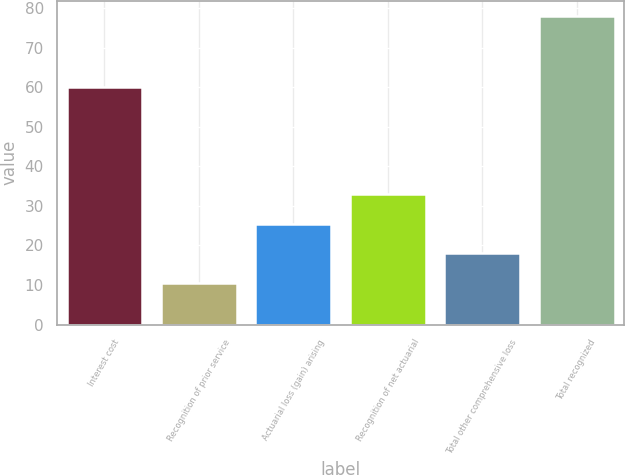<chart> <loc_0><loc_0><loc_500><loc_500><bar_chart><fcel>Interest cost<fcel>Recognition of prior service<fcel>Actuarial loss (gain) arising<fcel>Recognition of net actuarial<fcel>Total other comprehensive loss<fcel>Total recognized<nl><fcel>60<fcel>10.5<fcel>25.5<fcel>33<fcel>18<fcel>78<nl></chart> 